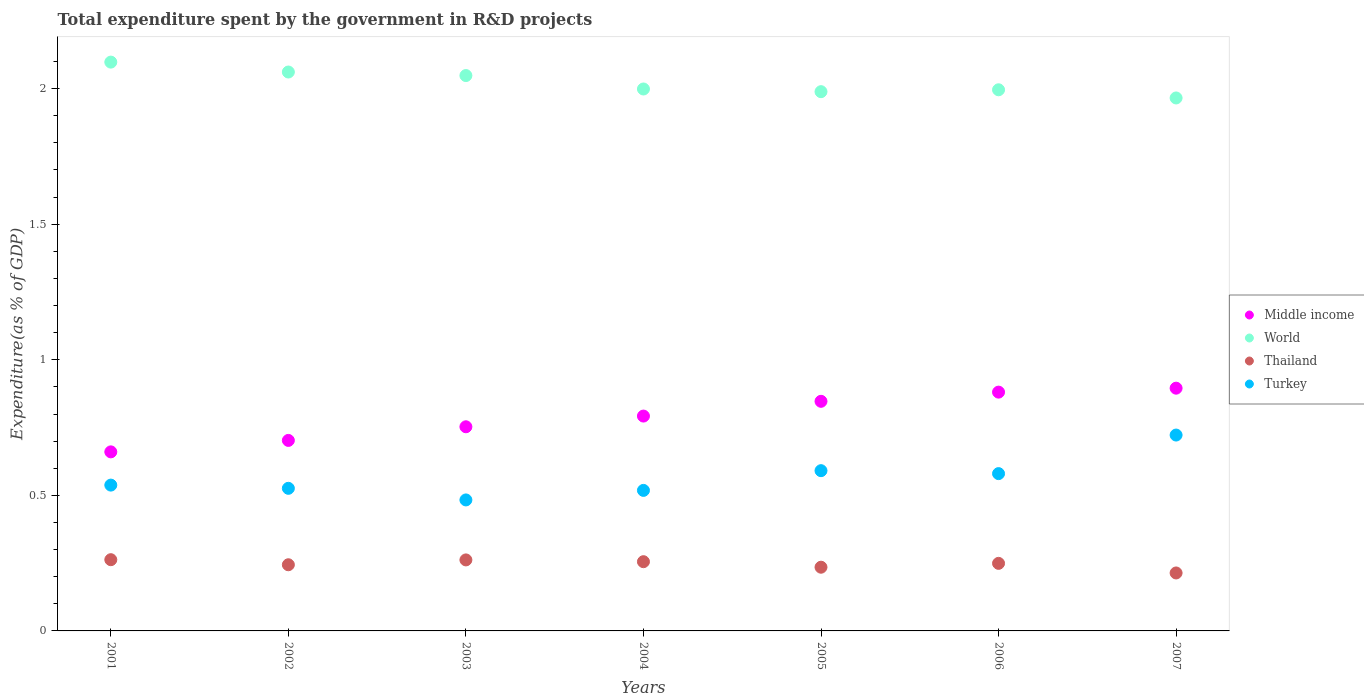How many different coloured dotlines are there?
Provide a short and direct response. 4. Is the number of dotlines equal to the number of legend labels?
Your answer should be compact. Yes. What is the total expenditure spent by the government in R&D projects in Middle income in 2001?
Offer a very short reply. 0.66. Across all years, what is the maximum total expenditure spent by the government in R&D projects in Turkey?
Your answer should be very brief. 0.72. Across all years, what is the minimum total expenditure spent by the government in R&D projects in Thailand?
Your answer should be very brief. 0.21. In which year was the total expenditure spent by the government in R&D projects in Thailand maximum?
Your answer should be compact. 2001. In which year was the total expenditure spent by the government in R&D projects in Middle income minimum?
Your response must be concise. 2001. What is the total total expenditure spent by the government in R&D projects in World in the graph?
Provide a succinct answer. 14.16. What is the difference between the total expenditure spent by the government in R&D projects in Thailand in 2001 and that in 2005?
Your answer should be very brief. 0.03. What is the difference between the total expenditure spent by the government in R&D projects in World in 2003 and the total expenditure spent by the government in R&D projects in Middle income in 2001?
Provide a succinct answer. 1.39. What is the average total expenditure spent by the government in R&D projects in Thailand per year?
Provide a succinct answer. 0.25. In the year 2001, what is the difference between the total expenditure spent by the government in R&D projects in Thailand and total expenditure spent by the government in R&D projects in Turkey?
Ensure brevity in your answer.  -0.28. In how many years, is the total expenditure spent by the government in R&D projects in Thailand greater than 0.6 %?
Make the answer very short. 0. What is the ratio of the total expenditure spent by the government in R&D projects in World in 2001 to that in 2007?
Ensure brevity in your answer.  1.07. Is the difference between the total expenditure spent by the government in R&D projects in Thailand in 2001 and 2006 greater than the difference between the total expenditure spent by the government in R&D projects in Turkey in 2001 and 2006?
Ensure brevity in your answer.  Yes. What is the difference between the highest and the second highest total expenditure spent by the government in R&D projects in Turkey?
Provide a succinct answer. 0.13. What is the difference between the highest and the lowest total expenditure spent by the government in R&D projects in Turkey?
Provide a short and direct response. 0.24. Is it the case that in every year, the sum of the total expenditure spent by the government in R&D projects in Turkey and total expenditure spent by the government in R&D projects in Middle income  is greater than the sum of total expenditure spent by the government in R&D projects in World and total expenditure spent by the government in R&D projects in Thailand?
Offer a very short reply. Yes. Is it the case that in every year, the sum of the total expenditure spent by the government in R&D projects in Turkey and total expenditure spent by the government in R&D projects in Middle income  is greater than the total expenditure spent by the government in R&D projects in Thailand?
Provide a short and direct response. Yes. How many years are there in the graph?
Give a very brief answer. 7. What is the difference between two consecutive major ticks on the Y-axis?
Give a very brief answer. 0.5. Are the values on the major ticks of Y-axis written in scientific E-notation?
Keep it short and to the point. No. Where does the legend appear in the graph?
Offer a very short reply. Center right. How many legend labels are there?
Offer a very short reply. 4. What is the title of the graph?
Provide a short and direct response. Total expenditure spent by the government in R&D projects. What is the label or title of the Y-axis?
Your answer should be very brief. Expenditure(as % of GDP). What is the Expenditure(as % of GDP) in Middle income in 2001?
Keep it short and to the point. 0.66. What is the Expenditure(as % of GDP) in World in 2001?
Keep it short and to the point. 2.1. What is the Expenditure(as % of GDP) of Thailand in 2001?
Your response must be concise. 0.26. What is the Expenditure(as % of GDP) of Turkey in 2001?
Keep it short and to the point. 0.54. What is the Expenditure(as % of GDP) of Middle income in 2002?
Provide a succinct answer. 0.7. What is the Expenditure(as % of GDP) in World in 2002?
Your answer should be very brief. 2.06. What is the Expenditure(as % of GDP) in Thailand in 2002?
Provide a succinct answer. 0.24. What is the Expenditure(as % of GDP) in Turkey in 2002?
Keep it short and to the point. 0.53. What is the Expenditure(as % of GDP) of Middle income in 2003?
Your answer should be compact. 0.75. What is the Expenditure(as % of GDP) of World in 2003?
Your answer should be very brief. 2.05. What is the Expenditure(as % of GDP) in Thailand in 2003?
Your answer should be compact. 0.26. What is the Expenditure(as % of GDP) of Turkey in 2003?
Offer a terse response. 0.48. What is the Expenditure(as % of GDP) in Middle income in 2004?
Provide a short and direct response. 0.79. What is the Expenditure(as % of GDP) in World in 2004?
Provide a short and direct response. 2. What is the Expenditure(as % of GDP) of Thailand in 2004?
Make the answer very short. 0.26. What is the Expenditure(as % of GDP) in Turkey in 2004?
Your answer should be compact. 0.52. What is the Expenditure(as % of GDP) in Middle income in 2005?
Give a very brief answer. 0.85. What is the Expenditure(as % of GDP) of World in 2005?
Your response must be concise. 1.99. What is the Expenditure(as % of GDP) in Thailand in 2005?
Ensure brevity in your answer.  0.23. What is the Expenditure(as % of GDP) of Turkey in 2005?
Your answer should be compact. 0.59. What is the Expenditure(as % of GDP) in Middle income in 2006?
Provide a succinct answer. 0.88. What is the Expenditure(as % of GDP) of World in 2006?
Give a very brief answer. 2. What is the Expenditure(as % of GDP) in Thailand in 2006?
Provide a short and direct response. 0.25. What is the Expenditure(as % of GDP) of Turkey in 2006?
Offer a very short reply. 0.58. What is the Expenditure(as % of GDP) in Middle income in 2007?
Give a very brief answer. 0.9. What is the Expenditure(as % of GDP) of World in 2007?
Provide a succinct answer. 1.97. What is the Expenditure(as % of GDP) in Thailand in 2007?
Offer a terse response. 0.21. What is the Expenditure(as % of GDP) in Turkey in 2007?
Your answer should be compact. 0.72. Across all years, what is the maximum Expenditure(as % of GDP) of Middle income?
Your answer should be compact. 0.9. Across all years, what is the maximum Expenditure(as % of GDP) of World?
Keep it short and to the point. 2.1. Across all years, what is the maximum Expenditure(as % of GDP) of Thailand?
Ensure brevity in your answer.  0.26. Across all years, what is the maximum Expenditure(as % of GDP) in Turkey?
Your answer should be very brief. 0.72. Across all years, what is the minimum Expenditure(as % of GDP) of Middle income?
Your answer should be very brief. 0.66. Across all years, what is the minimum Expenditure(as % of GDP) in World?
Give a very brief answer. 1.97. Across all years, what is the minimum Expenditure(as % of GDP) in Thailand?
Offer a very short reply. 0.21. Across all years, what is the minimum Expenditure(as % of GDP) in Turkey?
Keep it short and to the point. 0.48. What is the total Expenditure(as % of GDP) in Middle income in the graph?
Ensure brevity in your answer.  5.53. What is the total Expenditure(as % of GDP) in World in the graph?
Provide a short and direct response. 14.16. What is the total Expenditure(as % of GDP) in Thailand in the graph?
Provide a short and direct response. 1.72. What is the total Expenditure(as % of GDP) of Turkey in the graph?
Make the answer very short. 3.96. What is the difference between the Expenditure(as % of GDP) of Middle income in 2001 and that in 2002?
Give a very brief answer. -0.04. What is the difference between the Expenditure(as % of GDP) in World in 2001 and that in 2002?
Provide a succinct answer. 0.04. What is the difference between the Expenditure(as % of GDP) of Thailand in 2001 and that in 2002?
Offer a very short reply. 0.02. What is the difference between the Expenditure(as % of GDP) of Turkey in 2001 and that in 2002?
Make the answer very short. 0.01. What is the difference between the Expenditure(as % of GDP) in Middle income in 2001 and that in 2003?
Offer a terse response. -0.09. What is the difference between the Expenditure(as % of GDP) in World in 2001 and that in 2003?
Your response must be concise. 0.05. What is the difference between the Expenditure(as % of GDP) of Thailand in 2001 and that in 2003?
Provide a short and direct response. 0. What is the difference between the Expenditure(as % of GDP) in Turkey in 2001 and that in 2003?
Offer a terse response. 0.05. What is the difference between the Expenditure(as % of GDP) in Middle income in 2001 and that in 2004?
Provide a short and direct response. -0.13. What is the difference between the Expenditure(as % of GDP) of World in 2001 and that in 2004?
Make the answer very short. 0.1. What is the difference between the Expenditure(as % of GDP) of Thailand in 2001 and that in 2004?
Your response must be concise. 0.01. What is the difference between the Expenditure(as % of GDP) of Turkey in 2001 and that in 2004?
Offer a terse response. 0.02. What is the difference between the Expenditure(as % of GDP) in Middle income in 2001 and that in 2005?
Provide a short and direct response. -0.19. What is the difference between the Expenditure(as % of GDP) of World in 2001 and that in 2005?
Provide a succinct answer. 0.11. What is the difference between the Expenditure(as % of GDP) of Thailand in 2001 and that in 2005?
Offer a terse response. 0.03. What is the difference between the Expenditure(as % of GDP) of Turkey in 2001 and that in 2005?
Offer a terse response. -0.05. What is the difference between the Expenditure(as % of GDP) in Middle income in 2001 and that in 2006?
Ensure brevity in your answer.  -0.22. What is the difference between the Expenditure(as % of GDP) of World in 2001 and that in 2006?
Keep it short and to the point. 0.1. What is the difference between the Expenditure(as % of GDP) in Thailand in 2001 and that in 2006?
Provide a short and direct response. 0.01. What is the difference between the Expenditure(as % of GDP) in Turkey in 2001 and that in 2006?
Keep it short and to the point. -0.04. What is the difference between the Expenditure(as % of GDP) of Middle income in 2001 and that in 2007?
Keep it short and to the point. -0.23. What is the difference between the Expenditure(as % of GDP) in World in 2001 and that in 2007?
Offer a terse response. 0.13. What is the difference between the Expenditure(as % of GDP) of Thailand in 2001 and that in 2007?
Offer a terse response. 0.05. What is the difference between the Expenditure(as % of GDP) in Turkey in 2001 and that in 2007?
Provide a short and direct response. -0.18. What is the difference between the Expenditure(as % of GDP) in Middle income in 2002 and that in 2003?
Make the answer very short. -0.05. What is the difference between the Expenditure(as % of GDP) of World in 2002 and that in 2003?
Keep it short and to the point. 0.01. What is the difference between the Expenditure(as % of GDP) of Thailand in 2002 and that in 2003?
Provide a short and direct response. -0.02. What is the difference between the Expenditure(as % of GDP) in Turkey in 2002 and that in 2003?
Your answer should be very brief. 0.04. What is the difference between the Expenditure(as % of GDP) in Middle income in 2002 and that in 2004?
Ensure brevity in your answer.  -0.09. What is the difference between the Expenditure(as % of GDP) in World in 2002 and that in 2004?
Give a very brief answer. 0.06. What is the difference between the Expenditure(as % of GDP) of Thailand in 2002 and that in 2004?
Your answer should be compact. -0.01. What is the difference between the Expenditure(as % of GDP) of Turkey in 2002 and that in 2004?
Your response must be concise. 0.01. What is the difference between the Expenditure(as % of GDP) in Middle income in 2002 and that in 2005?
Your answer should be very brief. -0.14. What is the difference between the Expenditure(as % of GDP) in World in 2002 and that in 2005?
Your answer should be very brief. 0.07. What is the difference between the Expenditure(as % of GDP) of Thailand in 2002 and that in 2005?
Offer a very short reply. 0.01. What is the difference between the Expenditure(as % of GDP) of Turkey in 2002 and that in 2005?
Your answer should be compact. -0.07. What is the difference between the Expenditure(as % of GDP) of Middle income in 2002 and that in 2006?
Keep it short and to the point. -0.18. What is the difference between the Expenditure(as % of GDP) of World in 2002 and that in 2006?
Keep it short and to the point. 0.07. What is the difference between the Expenditure(as % of GDP) of Thailand in 2002 and that in 2006?
Your answer should be very brief. -0.01. What is the difference between the Expenditure(as % of GDP) of Turkey in 2002 and that in 2006?
Give a very brief answer. -0.05. What is the difference between the Expenditure(as % of GDP) in Middle income in 2002 and that in 2007?
Make the answer very short. -0.19. What is the difference between the Expenditure(as % of GDP) in World in 2002 and that in 2007?
Your answer should be very brief. 0.1. What is the difference between the Expenditure(as % of GDP) in Thailand in 2002 and that in 2007?
Offer a terse response. 0.03. What is the difference between the Expenditure(as % of GDP) of Turkey in 2002 and that in 2007?
Your answer should be very brief. -0.2. What is the difference between the Expenditure(as % of GDP) of Middle income in 2003 and that in 2004?
Your response must be concise. -0.04. What is the difference between the Expenditure(as % of GDP) of World in 2003 and that in 2004?
Offer a very short reply. 0.05. What is the difference between the Expenditure(as % of GDP) in Thailand in 2003 and that in 2004?
Your answer should be very brief. 0.01. What is the difference between the Expenditure(as % of GDP) of Turkey in 2003 and that in 2004?
Your answer should be compact. -0.04. What is the difference between the Expenditure(as % of GDP) of Middle income in 2003 and that in 2005?
Ensure brevity in your answer.  -0.09. What is the difference between the Expenditure(as % of GDP) of World in 2003 and that in 2005?
Ensure brevity in your answer.  0.06. What is the difference between the Expenditure(as % of GDP) of Thailand in 2003 and that in 2005?
Make the answer very short. 0.03. What is the difference between the Expenditure(as % of GDP) in Turkey in 2003 and that in 2005?
Provide a short and direct response. -0.11. What is the difference between the Expenditure(as % of GDP) in Middle income in 2003 and that in 2006?
Offer a terse response. -0.13. What is the difference between the Expenditure(as % of GDP) in World in 2003 and that in 2006?
Your answer should be very brief. 0.05. What is the difference between the Expenditure(as % of GDP) of Thailand in 2003 and that in 2006?
Offer a terse response. 0.01. What is the difference between the Expenditure(as % of GDP) of Turkey in 2003 and that in 2006?
Make the answer very short. -0.1. What is the difference between the Expenditure(as % of GDP) of Middle income in 2003 and that in 2007?
Provide a succinct answer. -0.14. What is the difference between the Expenditure(as % of GDP) of World in 2003 and that in 2007?
Give a very brief answer. 0.08. What is the difference between the Expenditure(as % of GDP) in Thailand in 2003 and that in 2007?
Your answer should be very brief. 0.05. What is the difference between the Expenditure(as % of GDP) of Turkey in 2003 and that in 2007?
Provide a short and direct response. -0.24. What is the difference between the Expenditure(as % of GDP) of Middle income in 2004 and that in 2005?
Ensure brevity in your answer.  -0.05. What is the difference between the Expenditure(as % of GDP) in World in 2004 and that in 2005?
Your answer should be very brief. 0.01. What is the difference between the Expenditure(as % of GDP) of Thailand in 2004 and that in 2005?
Your response must be concise. 0.02. What is the difference between the Expenditure(as % of GDP) in Turkey in 2004 and that in 2005?
Make the answer very short. -0.07. What is the difference between the Expenditure(as % of GDP) in Middle income in 2004 and that in 2006?
Ensure brevity in your answer.  -0.09. What is the difference between the Expenditure(as % of GDP) in World in 2004 and that in 2006?
Your response must be concise. 0. What is the difference between the Expenditure(as % of GDP) of Thailand in 2004 and that in 2006?
Make the answer very short. 0.01. What is the difference between the Expenditure(as % of GDP) of Turkey in 2004 and that in 2006?
Provide a succinct answer. -0.06. What is the difference between the Expenditure(as % of GDP) in Middle income in 2004 and that in 2007?
Ensure brevity in your answer.  -0.1. What is the difference between the Expenditure(as % of GDP) of World in 2004 and that in 2007?
Your answer should be compact. 0.03. What is the difference between the Expenditure(as % of GDP) in Thailand in 2004 and that in 2007?
Ensure brevity in your answer.  0.04. What is the difference between the Expenditure(as % of GDP) in Turkey in 2004 and that in 2007?
Make the answer very short. -0.2. What is the difference between the Expenditure(as % of GDP) of Middle income in 2005 and that in 2006?
Your answer should be very brief. -0.03. What is the difference between the Expenditure(as % of GDP) in World in 2005 and that in 2006?
Your answer should be very brief. -0.01. What is the difference between the Expenditure(as % of GDP) of Thailand in 2005 and that in 2006?
Your answer should be compact. -0.01. What is the difference between the Expenditure(as % of GDP) of Turkey in 2005 and that in 2006?
Provide a short and direct response. 0.01. What is the difference between the Expenditure(as % of GDP) in Middle income in 2005 and that in 2007?
Keep it short and to the point. -0.05. What is the difference between the Expenditure(as % of GDP) in World in 2005 and that in 2007?
Offer a very short reply. 0.02. What is the difference between the Expenditure(as % of GDP) of Thailand in 2005 and that in 2007?
Your response must be concise. 0.02. What is the difference between the Expenditure(as % of GDP) in Turkey in 2005 and that in 2007?
Provide a succinct answer. -0.13. What is the difference between the Expenditure(as % of GDP) in Middle income in 2006 and that in 2007?
Ensure brevity in your answer.  -0.01. What is the difference between the Expenditure(as % of GDP) of World in 2006 and that in 2007?
Your answer should be compact. 0.03. What is the difference between the Expenditure(as % of GDP) in Thailand in 2006 and that in 2007?
Keep it short and to the point. 0.04. What is the difference between the Expenditure(as % of GDP) in Turkey in 2006 and that in 2007?
Offer a very short reply. -0.14. What is the difference between the Expenditure(as % of GDP) in Middle income in 2001 and the Expenditure(as % of GDP) in World in 2002?
Give a very brief answer. -1.4. What is the difference between the Expenditure(as % of GDP) in Middle income in 2001 and the Expenditure(as % of GDP) in Thailand in 2002?
Give a very brief answer. 0.42. What is the difference between the Expenditure(as % of GDP) in Middle income in 2001 and the Expenditure(as % of GDP) in Turkey in 2002?
Keep it short and to the point. 0.13. What is the difference between the Expenditure(as % of GDP) in World in 2001 and the Expenditure(as % of GDP) in Thailand in 2002?
Ensure brevity in your answer.  1.85. What is the difference between the Expenditure(as % of GDP) in World in 2001 and the Expenditure(as % of GDP) in Turkey in 2002?
Offer a terse response. 1.57. What is the difference between the Expenditure(as % of GDP) of Thailand in 2001 and the Expenditure(as % of GDP) of Turkey in 2002?
Provide a succinct answer. -0.26. What is the difference between the Expenditure(as % of GDP) in Middle income in 2001 and the Expenditure(as % of GDP) in World in 2003?
Offer a very short reply. -1.39. What is the difference between the Expenditure(as % of GDP) of Middle income in 2001 and the Expenditure(as % of GDP) of Thailand in 2003?
Offer a very short reply. 0.4. What is the difference between the Expenditure(as % of GDP) in Middle income in 2001 and the Expenditure(as % of GDP) in Turkey in 2003?
Ensure brevity in your answer.  0.18. What is the difference between the Expenditure(as % of GDP) in World in 2001 and the Expenditure(as % of GDP) in Thailand in 2003?
Provide a succinct answer. 1.84. What is the difference between the Expenditure(as % of GDP) of World in 2001 and the Expenditure(as % of GDP) of Turkey in 2003?
Offer a terse response. 1.61. What is the difference between the Expenditure(as % of GDP) in Thailand in 2001 and the Expenditure(as % of GDP) in Turkey in 2003?
Your answer should be very brief. -0.22. What is the difference between the Expenditure(as % of GDP) in Middle income in 2001 and the Expenditure(as % of GDP) in World in 2004?
Give a very brief answer. -1.34. What is the difference between the Expenditure(as % of GDP) of Middle income in 2001 and the Expenditure(as % of GDP) of Thailand in 2004?
Ensure brevity in your answer.  0.41. What is the difference between the Expenditure(as % of GDP) of Middle income in 2001 and the Expenditure(as % of GDP) of Turkey in 2004?
Provide a succinct answer. 0.14. What is the difference between the Expenditure(as % of GDP) of World in 2001 and the Expenditure(as % of GDP) of Thailand in 2004?
Give a very brief answer. 1.84. What is the difference between the Expenditure(as % of GDP) of World in 2001 and the Expenditure(as % of GDP) of Turkey in 2004?
Your answer should be compact. 1.58. What is the difference between the Expenditure(as % of GDP) of Thailand in 2001 and the Expenditure(as % of GDP) of Turkey in 2004?
Keep it short and to the point. -0.26. What is the difference between the Expenditure(as % of GDP) of Middle income in 2001 and the Expenditure(as % of GDP) of World in 2005?
Your response must be concise. -1.33. What is the difference between the Expenditure(as % of GDP) of Middle income in 2001 and the Expenditure(as % of GDP) of Thailand in 2005?
Your answer should be very brief. 0.43. What is the difference between the Expenditure(as % of GDP) of Middle income in 2001 and the Expenditure(as % of GDP) of Turkey in 2005?
Your answer should be compact. 0.07. What is the difference between the Expenditure(as % of GDP) of World in 2001 and the Expenditure(as % of GDP) of Thailand in 2005?
Provide a succinct answer. 1.86. What is the difference between the Expenditure(as % of GDP) in World in 2001 and the Expenditure(as % of GDP) in Turkey in 2005?
Make the answer very short. 1.51. What is the difference between the Expenditure(as % of GDP) in Thailand in 2001 and the Expenditure(as % of GDP) in Turkey in 2005?
Ensure brevity in your answer.  -0.33. What is the difference between the Expenditure(as % of GDP) in Middle income in 2001 and the Expenditure(as % of GDP) in World in 2006?
Your response must be concise. -1.34. What is the difference between the Expenditure(as % of GDP) in Middle income in 2001 and the Expenditure(as % of GDP) in Thailand in 2006?
Ensure brevity in your answer.  0.41. What is the difference between the Expenditure(as % of GDP) in Middle income in 2001 and the Expenditure(as % of GDP) in Turkey in 2006?
Offer a very short reply. 0.08. What is the difference between the Expenditure(as % of GDP) of World in 2001 and the Expenditure(as % of GDP) of Thailand in 2006?
Provide a succinct answer. 1.85. What is the difference between the Expenditure(as % of GDP) of World in 2001 and the Expenditure(as % of GDP) of Turkey in 2006?
Ensure brevity in your answer.  1.52. What is the difference between the Expenditure(as % of GDP) in Thailand in 2001 and the Expenditure(as % of GDP) in Turkey in 2006?
Offer a very short reply. -0.32. What is the difference between the Expenditure(as % of GDP) of Middle income in 2001 and the Expenditure(as % of GDP) of World in 2007?
Give a very brief answer. -1.31. What is the difference between the Expenditure(as % of GDP) of Middle income in 2001 and the Expenditure(as % of GDP) of Thailand in 2007?
Provide a short and direct response. 0.45. What is the difference between the Expenditure(as % of GDP) of Middle income in 2001 and the Expenditure(as % of GDP) of Turkey in 2007?
Give a very brief answer. -0.06. What is the difference between the Expenditure(as % of GDP) of World in 2001 and the Expenditure(as % of GDP) of Thailand in 2007?
Your answer should be very brief. 1.88. What is the difference between the Expenditure(as % of GDP) of World in 2001 and the Expenditure(as % of GDP) of Turkey in 2007?
Ensure brevity in your answer.  1.38. What is the difference between the Expenditure(as % of GDP) in Thailand in 2001 and the Expenditure(as % of GDP) in Turkey in 2007?
Offer a terse response. -0.46. What is the difference between the Expenditure(as % of GDP) of Middle income in 2002 and the Expenditure(as % of GDP) of World in 2003?
Offer a terse response. -1.35. What is the difference between the Expenditure(as % of GDP) in Middle income in 2002 and the Expenditure(as % of GDP) in Thailand in 2003?
Offer a terse response. 0.44. What is the difference between the Expenditure(as % of GDP) in Middle income in 2002 and the Expenditure(as % of GDP) in Turkey in 2003?
Provide a short and direct response. 0.22. What is the difference between the Expenditure(as % of GDP) in World in 2002 and the Expenditure(as % of GDP) in Thailand in 2003?
Ensure brevity in your answer.  1.8. What is the difference between the Expenditure(as % of GDP) in World in 2002 and the Expenditure(as % of GDP) in Turkey in 2003?
Ensure brevity in your answer.  1.58. What is the difference between the Expenditure(as % of GDP) of Thailand in 2002 and the Expenditure(as % of GDP) of Turkey in 2003?
Offer a terse response. -0.24. What is the difference between the Expenditure(as % of GDP) of Middle income in 2002 and the Expenditure(as % of GDP) of World in 2004?
Your answer should be compact. -1.3. What is the difference between the Expenditure(as % of GDP) of Middle income in 2002 and the Expenditure(as % of GDP) of Thailand in 2004?
Give a very brief answer. 0.45. What is the difference between the Expenditure(as % of GDP) in Middle income in 2002 and the Expenditure(as % of GDP) in Turkey in 2004?
Provide a succinct answer. 0.18. What is the difference between the Expenditure(as % of GDP) of World in 2002 and the Expenditure(as % of GDP) of Thailand in 2004?
Offer a very short reply. 1.81. What is the difference between the Expenditure(as % of GDP) in World in 2002 and the Expenditure(as % of GDP) in Turkey in 2004?
Offer a very short reply. 1.54. What is the difference between the Expenditure(as % of GDP) in Thailand in 2002 and the Expenditure(as % of GDP) in Turkey in 2004?
Give a very brief answer. -0.27. What is the difference between the Expenditure(as % of GDP) in Middle income in 2002 and the Expenditure(as % of GDP) in World in 2005?
Your response must be concise. -1.29. What is the difference between the Expenditure(as % of GDP) of Middle income in 2002 and the Expenditure(as % of GDP) of Thailand in 2005?
Provide a short and direct response. 0.47. What is the difference between the Expenditure(as % of GDP) in Middle income in 2002 and the Expenditure(as % of GDP) in Turkey in 2005?
Offer a terse response. 0.11. What is the difference between the Expenditure(as % of GDP) of World in 2002 and the Expenditure(as % of GDP) of Thailand in 2005?
Give a very brief answer. 1.83. What is the difference between the Expenditure(as % of GDP) in World in 2002 and the Expenditure(as % of GDP) in Turkey in 2005?
Make the answer very short. 1.47. What is the difference between the Expenditure(as % of GDP) in Thailand in 2002 and the Expenditure(as % of GDP) in Turkey in 2005?
Your answer should be very brief. -0.35. What is the difference between the Expenditure(as % of GDP) of Middle income in 2002 and the Expenditure(as % of GDP) of World in 2006?
Your answer should be very brief. -1.29. What is the difference between the Expenditure(as % of GDP) of Middle income in 2002 and the Expenditure(as % of GDP) of Thailand in 2006?
Your response must be concise. 0.45. What is the difference between the Expenditure(as % of GDP) in Middle income in 2002 and the Expenditure(as % of GDP) in Turkey in 2006?
Ensure brevity in your answer.  0.12. What is the difference between the Expenditure(as % of GDP) of World in 2002 and the Expenditure(as % of GDP) of Thailand in 2006?
Provide a succinct answer. 1.81. What is the difference between the Expenditure(as % of GDP) in World in 2002 and the Expenditure(as % of GDP) in Turkey in 2006?
Provide a short and direct response. 1.48. What is the difference between the Expenditure(as % of GDP) of Thailand in 2002 and the Expenditure(as % of GDP) of Turkey in 2006?
Your answer should be very brief. -0.34. What is the difference between the Expenditure(as % of GDP) of Middle income in 2002 and the Expenditure(as % of GDP) of World in 2007?
Your response must be concise. -1.26. What is the difference between the Expenditure(as % of GDP) of Middle income in 2002 and the Expenditure(as % of GDP) of Thailand in 2007?
Give a very brief answer. 0.49. What is the difference between the Expenditure(as % of GDP) in Middle income in 2002 and the Expenditure(as % of GDP) in Turkey in 2007?
Your answer should be compact. -0.02. What is the difference between the Expenditure(as % of GDP) of World in 2002 and the Expenditure(as % of GDP) of Thailand in 2007?
Offer a very short reply. 1.85. What is the difference between the Expenditure(as % of GDP) in World in 2002 and the Expenditure(as % of GDP) in Turkey in 2007?
Offer a terse response. 1.34. What is the difference between the Expenditure(as % of GDP) in Thailand in 2002 and the Expenditure(as % of GDP) in Turkey in 2007?
Your answer should be very brief. -0.48. What is the difference between the Expenditure(as % of GDP) of Middle income in 2003 and the Expenditure(as % of GDP) of World in 2004?
Keep it short and to the point. -1.25. What is the difference between the Expenditure(as % of GDP) in Middle income in 2003 and the Expenditure(as % of GDP) in Thailand in 2004?
Make the answer very short. 0.5. What is the difference between the Expenditure(as % of GDP) in Middle income in 2003 and the Expenditure(as % of GDP) in Turkey in 2004?
Provide a succinct answer. 0.23. What is the difference between the Expenditure(as % of GDP) of World in 2003 and the Expenditure(as % of GDP) of Thailand in 2004?
Provide a short and direct response. 1.79. What is the difference between the Expenditure(as % of GDP) in World in 2003 and the Expenditure(as % of GDP) in Turkey in 2004?
Give a very brief answer. 1.53. What is the difference between the Expenditure(as % of GDP) of Thailand in 2003 and the Expenditure(as % of GDP) of Turkey in 2004?
Your answer should be very brief. -0.26. What is the difference between the Expenditure(as % of GDP) of Middle income in 2003 and the Expenditure(as % of GDP) of World in 2005?
Keep it short and to the point. -1.24. What is the difference between the Expenditure(as % of GDP) in Middle income in 2003 and the Expenditure(as % of GDP) in Thailand in 2005?
Ensure brevity in your answer.  0.52. What is the difference between the Expenditure(as % of GDP) of Middle income in 2003 and the Expenditure(as % of GDP) of Turkey in 2005?
Make the answer very short. 0.16. What is the difference between the Expenditure(as % of GDP) in World in 2003 and the Expenditure(as % of GDP) in Thailand in 2005?
Offer a very short reply. 1.81. What is the difference between the Expenditure(as % of GDP) of World in 2003 and the Expenditure(as % of GDP) of Turkey in 2005?
Offer a terse response. 1.46. What is the difference between the Expenditure(as % of GDP) of Thailand in 2003 and the Expenditure(as % of GDP) of Turkey in 2005?
Provide a short and direct response. -0.33. What is the difference between the Expenditure(as % of GDP) of Middle income in 2003 and the Expenditure(as % of GDP) of World in 2006?
Provide a succinct answer. -1.24. What is the difference between the Expenditure(as % of GDP) of Middle income in 2003 and the Expenditure(as % of GDP) of Thailand in 2006?
Offer a terse response. 0.5. What is the difference between the Expenditure(as % of GDP) of Middle income in 2003 and the Expenditure(as % of GDP) of Turkey in 2006?
Provide a succinct answer. 0.17. What is the difference between the Expenditure(as % of GDP) of World in 2003 and the Expenditure(as % of GDP) of Thailand in 2006?
Your answer should be very brief. 1.8. What is the difference between the Expenditure(as % of GDP) in World in 2003 and the Expenditure(as % of GDP) in Turkey in 2006?
Offer a terse response. 1.47. What is the difference between the Expenditure(as % of GDP) of Thailand in 2003 and the Expenditure(as % of GDP) of Turkey in 2006?
Your response must be concise. -0.32. What is the difference between the Expenditure(as % of GDP) of Middle income in 2003 and the Expenditure(as % of GDP) of World in 2007?
Make the answer very short. -1.21. What is the difference between the Expenditure(as % of GDP) in Middle income in 2003 and the Expenditure(as % of GDP) in Thailand in 2007?
Your answer should be very brief. 0.54. What is the difference between the Expenditure(as % of GDP) of Middle income in 2003 and the Expenditure(as % of GDP) of Turkey in 2007?
Make the answer very short. 0.03. What is the difference between the Expenditure(as % of GDP) in World in 2003 and the Expenditure(as % of GDP) in Thailand in 2007?
Your answer should be compact. 1.83. What is the difference between the Expenditure(as % of GDP) of World in 2003 and the Expenditure(as % of GDP) of Turkey in 2007?
Keep it short and to the point. 1.33. What is the difference between the Expenditure(as % of GDP) in Thailand in 2003 and the Expenditure(as % of GDP) in Turkey in 2007?
Provide a short and direct response. -0.46. What is the difference between the Expenditure(as % of GDP) of Middle income in 2004 and the Expenditure(as % of GDP) of World in 2005?
Give a very brief answer. -1.2. What is the difference between the Expenditure(as % of GDP) in Middle income in 2004 and the Expenditure(as % of GDP) in Thailand in 2005?
Provide a short and direct response. 0.56. What is the difference between the Expenditure(as % of GDP) in Middle income in 2004 and the Expenditure(as % of GDP) in Turkey in 2005?
Keep it short and to the point. 0.2. What is the difference between the Expenditure(as % of GDP) of World in 2004 and the Expenditure(as % of GDP) of Thailand in 2005?
Make the answer very short. 1.76. What is the difference between the Expenditure(as % of GDP) in World in 2004 and the Expenditure(as % of GDP) in Turkey in 2005?
Your response must be concise. 1.41. What is the difference between the Expenditure(as % of GDP) in Thailand in 2004 and the Expenditure(as % of GDP) in Turkey in 2005?
Offer a very short reply. -0.34. What is the difference between the Expenditure(as % of GDP) in Middle income in 2004 and the Expenditure(as % of GDP) in World in 2006?
Make the answer very short. -1.2. What is the difference between the Expenditure(as % of GDP) of Middle income in 2004 and the Expenditure(as % of GDP) of Thailand in 2006?
Your answer should be compact. 0.54. What is the difference between the Expenditure(as % of GDP) in Middle income in 2004 and the Expenditure(as % of GDP) in Turkey in 2006?
Provide a short and direct response. 0.21. What is the difference between the Expenditure(as % of GDP) of World in 2004 and the Expenditure(as % of GDP) of Thailand in 2006?
Keep it short and to the point. 1.75. What is the difference between the Expenditure(as % of GDP) in World in 2004 and the Expenditure(as % of GDP) in Turkey in 2006?
Keep it short and to the point. 1.42. What is the difference between the Expenditure(as % of GDP) in Thailand in 2004 and the Expenditure(as % of GDP) in Turkey in 2006?
Make the answer very short. -0.32. What is the difference between the Expenditure(as % of GDP) of Middle income in 2004 and the Expenditure(as % of GDP) of World in 2007?
Ensure brevity in your answer.  -1.17. What is the difference between the Expenditure(as % of GDP) in Middle income in 2004 and the Expenditure(as % of GDP) in Thailand in 2007?
Your response must be concise. 0.58. What is the difference between the Expenditure(as % of GDP) of Middle income in 2004 and the Expenditure(as % of GDP) of Turkey in 2007?
Offer a very short reply. 0.07. What is the difference between the Expenditure(as % of GDP) of World in 2004 and the Expenditure(as % of GDP) of Thailand in 2007?
Give a very brief answer. 1.78. What is the difference between the Expenditure(as % of GDP) of World in 2004 and the Expenditure(as % of GDP) of Turkey in 2007?
Your answer should be very brief. 1.28. What is the difference between the Expenditure(as % of GDP) in Thailand in 2004 and the Expenditure(as % of GDP) in Turkey in 2007?
Offer a very short reply. -0.47. What is the difference between the Expenditure(as % of GDP) in Middle income in 2005 and the Expenditure(as % of GDP) in World in 2006?
Make the answer very short. -1.15. What is the difference between the Expenditure(as % of GDP) in Middle income in 2005 and the Expenditure(as % of GDP) in Thailand in 2006?
Your response must be concise. 0.6. What is the difference between the Expenditure(as % of GDP) of Middle income in 2005 and the Expenditure(as % of GDP) of Turkey in 2006?
Make the answer very short. 0.27. What is the difference between the Expenditure(as % of GDP) in World in 2005 and the Expenditure(as % of GDP) in Thailand in 2006?
Your answer should be very brief. 1.74. What is the difference between the Expenditure(as % of GDP) of World in 2005 and the Expenditure(as % of GDP) of Turkey in 2006?
Ensure brevity in your answer.  1.41. What is the difference between the Expenditure(as % of GDP) of Thailand in 2005 and the Expenditure(as % of GDP) of Turkey in 2006?
Offer a very short reply. -0.35. What is the difference between the Expenditure(as % of GDP) in Middle income in 2005 and the Expenditure(as % of GDP) in World in 2007?
Give a very brief answer. -1.12. What is the difference between the Expenditure(as % of GDP) in Middle income in 2005 and the Expenditure(as % of GDP) in Thailand in 2007?
Give a very brief answer. 0.63. What is the difference between the Expenditure(as % of GDP) of Middle income in 2005 and the Expenditure(as % of GDP) of Turkey in 2007?
Your response must be concise. 0.12. What is the difference between the Expenditure(as % of GDP) in World in 2005 and the Expenditure(as % of GDP) in Thailand in 2007?
Your response must be concise. 1.78. What is the difference between the Expenditure(as % of GDP) in World in 2005 and the Expenditure(as % of GDP) in Turkey in 2007?
Make the answer very short. 1.27. What is the difference between the Expenditure(as % of GDP) of Thailand in 2005 and the Expenditure(as % of GDP) of Turkey in 2007?
Your answer should be compact. -0.49. What is the difference between the Expenditure(as % of GDP) of Middle income in 2006 and the Expenditure(as % of GDP) of World in 2007?
Keep it short and to the point. -1.08. What is the difference between the Expenditure(as % of GDP) in Middle income in 2006 and the Expenditure(as % of GDP) in Thailand in 2007?
Offer a terse response. 0.67. What is the difference between the Expenditure(as % of GDP) in Middle income in 2006 and the Expenditure(as % of GDP) in Turkey in 2007?
Your answer should be compact. 0.16. What is the difference between the Expenditure(as % of GDP) in World in 2006 and the Expenditure(as % of GDP) in Thailand in 2007?
Make the answer very short. 1.78. What is the difference between the Expenditure(as % of GDP) in World in 2006 and the Expenditure(as % of GDP) in Turkey in 2007?
Offer a very short reply. 1.27. What is the difference between the Expenditure(as % of GDP) in Thailand in 2006 and the Expenditure(as % of GDP) in Turkey in 2007?
Keep it short and to the point. -0.47. What is the average Expenditure(as % of GDP) of Middle income per year?
Your response must be concise. 0.79. What is the average Expenditure(as % of GDP) in World per year?
Give a very brief answer. 2.02. What is the average Expenditure(as % of GDP) of Thailand per year?
Your answer should be very brief. 0.25. What is the average Expenditure(as % of GDP) in Turkey per year?
Make the answer very short. 0.57. In the year 2001, what is the difference between the Expenditure(as % of GDP) of Middle income and Expenditure(as % of GDP) of World?
Ensure brevity in your answer.  -1.44. In the year 2001, what is the difference between the Expenditure(as % of GDP) in Middle income and Expenditure(as % of GDP) in Thailand?
Offer a very short reply. 0.4. In the year 2001, what is the difference between the Expenditure(as % of GDP) of Middle income and Expenditure(as % of GDP) of Turkey?
Provide a succinct answer. 0.12. In the year 2001, what is the difference between the Expenditure(as % of GDP) of World and Expenditure(as % of GDP) of Thailand?
Provide a short and direct response. 1.84. In the year 2001, what is the difference between the Expenditure(as % of GDP) of World and Expenditure(as % of GDP) of Turkey?
Provide a succinct answer. 1.56. In the year 2001, what is the difference between the Expenditure(as % of GDP) of Thailand and Expenditure(as % of GDP) of Turkey?
Your response must be concise. -0.28. In the year 2002, what is the difference between the Expenditure(as % of GDP) in Middle income and Expenditure(as % of GDP) in World?
Make the answer very short. -1.36. In the year 2002, what is the difference between the Expenditure(as % of GDP) in Middle income and Expenditure(as % of GDP) in Thailand?
Your answer should be compact. 0.46. In the year 2002, what is the difference between the Expenditure(as % of GDP) in Middle income and Expenditure(as % of GDP) in Turkey?
Your answer should be very brief. 0.18. In the year 2002, what is the difference between the Expenditure(as % of GDP) in World and Expenditure(as % of GDP) in Thailand?
Make the answer very short. 1.82. In the year 2002, what is the difference between the Expenditure(as % of GDP) in World and Expenditure(as % of GDP) in Turkey?
Make the answer very short. 1.54. In the year 2002, what is the difference between the Expenditure(as % of GDP) in Thailand and Expenditure(as % of GDP) in Turkey?
Offer a terse response. -0.28. In the year 2003, what is the difference between the Expenditure(as % of GDP) in Middle income and Expenditure(as % of GDP) in World?
Provide a succinct answer. -1.3. In the year 2003, what is the difference between the Expenditure(as % of GDP) of Middle income and Expenditure(as % of GDP) of Thailand?
Give a very brief answer. 0.49. In the year 2003, what is the difference between the Expenditure(as % of GDP) in Middle income and Expenditure(as % of GDP) in Turkey?
Ensure brevity in your answer.  0.27. In the year 2003, what is the difference between the Expenditure(as % of GDP) in World and Expenditure(as % of GDP) in Thailand?
Keep it short and to the point. 1.79. In the year 2003, what is the difference between the Expenditure(as % of GDP) in World and Expenditure(as % of GDP) in Turkey?
Provide a short and direct response. 1.57. In the year 2003, what is the difference between the Expenditure(as % of GDP) of Thailand and Expenditure(as % of GDP) of Turkey?
Offer a very short reply. -0.22. In the year 2004, what is the difference between the Expenditure(as % of GDP) of Middle income and Expenditure(as % of GDP) of World?
Your answer should be very brief. -1.21. In the year 2004, what is the difference between the Expenditure(as % of GDP) of Middle income and Expenditure(as % of GDP) of Thailand?
Your answer should be compact. 0.54. In the year 2004, what is the difference between the Expenditure(as % of GDP) of Middle income and Expenditure(as % of GDP) of Turkey?
Provide a succinct answer. 0.27. In the year 2004, what is the difference between the Expenditure(as % of GDP) in World and Expenditure(as % of GDP) in Thailand?
Provide a succinct answer. 1.74. In the year 2004, what is the difference between the Expenditure(as % of GDP) in World and Expenditure(as % of GDP) in Turkey?
Offer a very short reply. 1.48. In the year 2004, what is the difference between the Expenditure(as % of GDP) in Thailand and Expenditure(as % of GDP) in Turkey?
Your response must be concise. -0.26. In the year 2005, what is the difference between the Expenditure(as % of GDP) in Middle income and Expenditure(as % of GDP) in World?
Your answer should be compact. -1.14. In the year 2005, what is the difference between the Expenditure(as % of GDP) of Middle income and Expenditure(as % of GDP) of Thailand?
Offer a terse response. 0.61. In the year 2005, what is the difference between the Expenditure(as % of GDP) in Middle income and Expenditure(as % of GDP) in Turkey?
Provide a succinct answer. 0.26. In the year 2005, what is the difference between the Expenditure(as % of GDP) in World and Expenditure(as % of GDP) in Thailand?
Keep it short and to the point. 1.75. In the year 2005, what is the difference between the Expenditure(as % of GDP) in World and Expenditure(as % of GDP) in Turkey?
Provide a succinct answer. 1.4. In the year 2005, what is the difference between the Expenditure(as % of GDP) of Thailand and Expenditure(as % of GDP) of Turkey?
Make the answer very short. -0.36. In the year 2006, what is the difference between the Expenditure(as % of GDP) in Middle income and Expenditure(as % of GDP) in World?
Provide a succinct answer. -1.12. In the year 2006, what is the difference between the Expenditure(as % of GDP) of Middle income and Expenditure(as % of GDP) of Thailand?
Ensure brevity in your answer.  0.63. In the year 2006, what is the difference between the Expenditure(as % of GDP) in Middle income and Expenditure(as % of GDP) in Turkey?
Your response must be concise. 0.3. In the year 2006, what is the difference between the Expenditure(as % of GDP) in World and Expenditure(as % of GDP) in Thailand?
Offer a terse response. 1.75. In the year 2006, what is the difference between the Expenditure(as % of GDP) in World and Expenditure(as % of GDP) in Turkey?
Give a very brief answer. 1.42. In the year 2006, what is the difference between the Expenditure(as % of GDP) in Thailand and Expenditure(as % of GDP) in Turkey?
Offer a very short reply. -0.33. In the year 2007, what is the difference between the Expenditure(as % of GDP) in Middle income and Expenditure(as % of GDP) in World?
Your answer should be compact. -1.07. In the year 2007, what is the difference between the Expenditure(as % of GDP) in Middle income and Expenditure(as % of GDP) in Thailand?
Offer a very short reply. 0.68. In the year 2007, what is the difference between the Expenditure(as % of GDP) in Middle income and Expenditure(as % of GDP) in Turkey?
Provide a short and direct response. 0.17. In the year 2007, what is the difference between the Expenditure(as % of GDP) in World and Expenditure(as % of GDP) in Thailand?
Your answer should be compact. 1.75. In the year 2007, what is the difference between the Expenditure(as % of GDP) in World and Expenditure(as % of GDP) in Turkey?
Ensure brevity in your answer.  1.24. In the year 2007, what is the difference between the Expenditure(as % of GDP) in Thailand and Expenditure(as % of GDP) in Turkey?
Keep it short and to the point. -0.51. What is the ratio of the Expenditure(as % of GDP) in Middle income in 2001 to that in 2002?
Your answer should be very brief. 0.94. What is the ratio of the Expenditure(as % of GDP) in World in 2001 to that in 2002?
Give a very brief answer. 1.02. What is the ratio of the Expenditure(as % of GDP) of Thailand in 2001 to that in 2002?
Ensure brevity in your answer.  1.08. What is the ratio of the Expenditure(as % of GDP) of Turkey in 2001 to that in 2002?
Your answer should be compact. 1.02. What is the ratio of the Expenditure(as % of GDP) in Middle income in 2001 to that in 2003?
Your answer should be compact. 0.88. What is the ratio of the Expenditure(as % of GDP) of World in 2001 to that in 2003?
Your answer should be compact. 1.02. What is the ratio of the Expenditure(as % of GDP) in Thailand in 2001 to that in 2003?
Your response must be concise. 1. What is the ratio of the Expenditure(as % of GDP) of Turkey in 2001 to that in 2003?
Make the answer very short. 1.11. What is the ratio of the Expenditure(as % of GDP) of Middle income in 2001 to that in 2004?
Provide a short and direct response. 0.83. What is the ratio of the Expenditure(as % of GDP) in World in 2001 to that in 2004?
Make the answer very short. 1.05. What is the ratio of the Expenditure(as % of GDP) of Thailand in 2001 to that in 2004?
Your response must be concise. 1.03. What is the ratio of the Expenditure(as % of GDP) of Turkey in 2001 to that in 2004?
Give a very brief answer. 1.04. What is the ratio of the Expenditure(as % of GDP) in Middle income in 2001 to that in 2005?
Make the answer very short. 0.78. What is the ratio of the Expenditure(as % of GDP) of World in 2001 to that in 2005?
Offer a very short reply. 1.05. What is the ratio of the Expenditure(as % of GDP) in Thailand in 2001 to that in 2005?
Provide a succinct answer. 1.12. What is the ratio of the Expenditure(as % of GDP) in Turkey in 2001 to that in 2005?
Provide a succinct answer. 0.91. What is the ratio of the Expenditure(as % of GDP) in Middle income in 2001 to that in 2006?
Offer a very short reply. 0.75. What is the ratio of the Expenditure(as % of GDP) of World in 2001 to that in 2006?
Offer a very short reply. 1.05. What is the ratio of the Expenditure(as % of GDP) of Thailand in 2001 to that in 2006?
Keep it short and to the point. 1.05. What is the ratio of the Expenditure(as % of GDP) in Turkey in 2001 to that in 2006?
Your answer should be compact. 0.93. What is the ratio of the Expenditure(as % of GDP) of Middle income in 2001 to that in 2007?
Make the answer very short. 0.74. What is the ratio of the Expenditure(as % of GDP) in World in 2001 to that in 2007?
Offer a very short reply. 1.07. What is the ratio of the Expenditure(as % of GDP) in Thailand in 2001 to that in 2007?
Provide a succinct answer. 1.23. What is the ratio of the Expenditure(as % of GDP) of Turkey in 2001 to that in 2007?
Ensure brevity in your answer.  0.74. What is the ratio of the Expenditure(as % of GDP) in Middle income in 2002 to that in 2003?
Keep it short and to the point. 0.93. What is the ratio of the Expenditure(as % of GDP) in World in 2002 to that in 2003?
Give a very brief answer. 1.01. What is the ratio of the Expenditure(as % of GDP) of Thailand in 2002 to that in 2003?
Keep it short and to the point. 0.93. What is the ratio of the Expenditure(as % of GDP) in Turkey in 2002 to that in 2003?
Keep it short and to the point. 1.09. What is the ratio of the Expenditure(as % of GDP) of Middle income in 2002 to that in 2004?
Offer a terse response. 0.89. What is the ratio of the Expenditure(as % of GDP) of World in 2002 to that in 2004?
Keep it short and to the point. 1.03. What is the ratio of the Expenditure(as % of GDP) in Thailand in 2002 to that in 2004?
Give a very brief answer. 0.96. What is the ratio of the Expenditure(as % of GDP) in Turkey in 2002 to that in 2004?
Make the answer very short. 1.01. What is the ratio of the Expenditure(as % of GDP) of Middle income in 2002 to that in 2005?
Give a very brief answer. 0.83. What is the ratio of the Expenditure(as % of GDP) in World in 2002 to that in 2005?
Provide a succinct answer. 1.04. What is the ratio of the Expenditure(as % of GDP) in Thailand in 2002 to that in 2005?
Your answer should be very brief. 1.04. What is the ratio of the Expenditure(as % of GDP) in Turkey in 2002 to that in 2005?
Offer a terse response. 0.89. What is the ratio of the Expenditure(as % of GDP) of Middle income in 2002 to that in 2006?
Give a very brief answer. 0.8. What is the ratio of the Expenditure(as % of GDP) in World in 2002 to that in 2006?
Your response must be concise. 1.03. What is the ratio of the Expenditure(as % of GDP) of Thailand in 2002 to that in 2006?
Your response must be concise. 0.98. What is the ratio of the Expenditure(as % of GDP) of Turkey in 2002 to that in 2006?
Give a very brief answer. 0.91. What is the ratio of the Expenditure(as % of GDP) in Middle income in 2002 to that in 2007?
Your response must be concise. 0.78. What is the ratio of the Expenditure(as % of GDP) of World in 2002 to that in 2007?
Your answer should be very brief. 1.05. What is the ratio of the Expenditure(as % of GDP) of Thailand in 2002 to that in 2007?
Your response must be concise. 1.14. What is the ratio of the Expenditure(as % of GDP) in Turkey in 2002 to that in 2007?
Provide a succinct answer. 0.73. What is the ratio of the Expenditure(as % of GDP) in Middle income in 2003 to that in 2004?
Offer a very short reply. 0.95. What is the ratio of the Expenditure(as % of GDP) of World in 2003 to that in 2004?
Offer a terse response. 1.02. What is the ratio of the Expenditure(as % of GDP) in Thailand in 2003 to that in 2004?
Offer a very short reply. 1.03. What is the ratio of the Expenditure(as % of GDP) in Turkey in 2003 to that in 2004?
Your response must be concise. 0.93. What is the ratio of the Expenditure(as % of GDP) of Middle income in 2003 to that in 2005?
Offer a very short reply. 0.89. What is the ratio of the Expenditure(as % of GDP) in World in 2003 to that in 2005?
Provide a short and direct response. 1.03. What is the ratio of the Expenditure(as % of GDP) of Thailand in 2003 to that in 2005?
Provide a succinct answer. 1.11. What is the ratio of the Expenditure(as % of GDP) in Turkey in 2003 to that in 2005?
Offer a very short reply. 0.82. What is the ratio of the Expenditure(as % of GDP) in Middle income in 2003 to that in 2006?
Provide a short and direct response. 0.85. What is the ratio of the Expenditure(as % of GDP) of World in 2003 to that in 2006?
Make the answer very short. 1.03. What is the ratio of the Expenditure(as % of GDP) in Thailand in 2003 to that in 2006?
Your answer should be compact. 1.05. What is the ratio of the Expenditure(as % of GDP) in Turkey in 2003 to that in 2006?
Your answer should be compact. 0.83. What is the ratio of the Expenditure(as % of GDP) in Middle income in 2003 to that in 2007?
Offer a very short reply. 0.84. What is the ratio of the Expenditure(as % of GDP) in World in 2003 to that in 2007?
Offer a terse response. 1.04. What is the ratio of the Expenditure(as % of GDP) of Thailand in 2003 to that in 2007?
Give a very brief answer. 1.23. What is the ratio of the Expenditure(as % of GDP) of Turkey in 2003 to that in 2007?
Your answer should be very brief. 0.67. What is the ratio of the Expenditure(as % of GDP) in Middle income in 2004 to that in 2005?
Make the answer very short. 0.94. What is the ratio of the Expenditure(as % of GDP) of Thailand in 2004 to that in 2005?
Make the answer very short. 1.09. What is the ratio of the Expenditure(as % of GDP) in Turkey in 2004 to that in 2005?
Ensure brevity in your answer.  0.88. What is the ratio of the Expenditure(as % of GDP) in Middle income in 2004 to that in 2006?
Your response must be concise. 0.9. What is the ratio of the Expenditure(as % of GDP) in World in 2004 to that in 2006?
Make the answer very short. 1. What is the ratio of the Expenditure(as % of GDP) in Thailand in 2004 to that in 2006?
Provide a short and direct response. 1.02. What is the ratio of the Expenditure(as % of GDP) of Turkey in 2004 to that in 2006?
Provide a succinct answer. 0.89. What is the ratio of the Expenditure(as % of GDP) of Middle income in 2004 to that in 2007?
Make the answer very short. 0.89. What is the ratio of the Expenditure(as % of GDP) in World in 2004 to that in 2007?
Offer a terse response. 1.02. What is the ratio of the Expenditure(as % of GDP) in Thailand in 2004 to that in 2007?
Give a very brief answer. 1.19. What is the ratio of the Expenditure(as % of GDP) of Turkey in 2004 to that in 2007?
Your answer should be compact. 0.72. What is the ratio of the Expenditure(as % of GDP) in Middle income in 2005 to that in 2006?
Make the answer very short. 0.96. What is the ratio of the Expenditure(as % of GDP) in World in 2005 to that in 2006?
Your response must be concise. 1. What is the ratio of the Expenditure(as % of GDP) in Thailand in 2005 to that in 2006?
Your answer should be compact. 0.94. What is the ratio of the Expenditure(as % of GDP) in Turkey in 2005 to that in 2006?
Offer a very short reply. 1.02. What is the ratio of the Expenditure(as % of GDP) of Middle income in 2005 to that in 2007?
Your answer should be compact. 0.95. What is the ratio of the Expenditure(as % of GDP) in World in 2005 to that in 2007?
Give a very brief answer. 1.01. What is the ratio of the Expenditure(as % of GDP) of Thailand in 2005 to that in 2007?
Your answer should be compact. 1.1. What is the ratio of the Expenditure(as % of GDP) of Turkey in 2005 to that in 2007?
Give a very brief answer. 0.82. What is the ratio of the Expenditure(as % of GDP) in Middle income in 2006 to that in 2007?
Give a very brief answer. 0.98. What is the ratio of the Expenditure(as % of GDP) in World in 2006 to that in 2007?
Your answer should be very brief. 1.02. What is the ratio of the Expenditure(as % of GDP) of Thailand in 2006 to that in 2007?
Your answer should be very brief. 1.17. What is the ratio of the Expenditure(as % of GDP) of Turkey in 2006 to that in 2007?
Your answer should be compact. 0.8. What is the difference between the highest and the second highest Expenditure(as % of GDP) in Middle income?
Give a very brief answer. 0.01. What is the difference between the highest and the second highest Expenditure(as % of GDP) in World?
Provide a succinct answer. 0.04. What is the difference between the highest and the second highest Expenditure(as % of GDP) in Thailand?
Offer a very short reply. 0. What is the difference between the highest and the second highest Expenditure(as % of GDP) in Turkey?
Your response must be concise. 0.13. What is the difference between the highest and the lowest Expenditure(as % of GDP) in Middle income?
Give a very brief answer. 0.23. What is the difference between the highest and the lowest Expenditure(as % of GDP) in World?
Your answer should be very brief. 0.13. What is the difference between the highest and the lowest Expenditure(as % of GDP) in Thailand?
Provide a succinct answer. 0.05. What is the difference between the highest and the lowest Expenditure(as % of GDP) in Turkey?
Give a very brief answer. 0.24. 